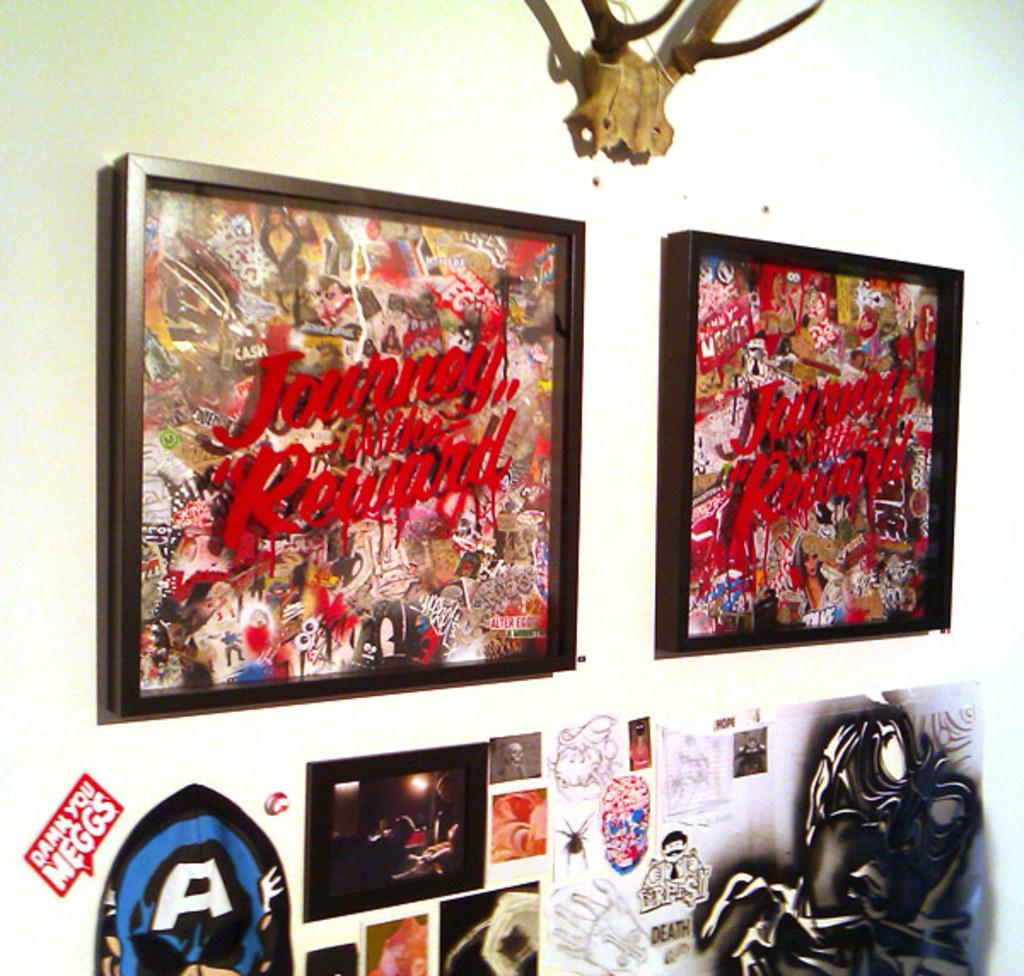Provide a one-sentence caption for the provided image. A wall with a few pictures displayed and a sticker saying "Damn you Meggs". 